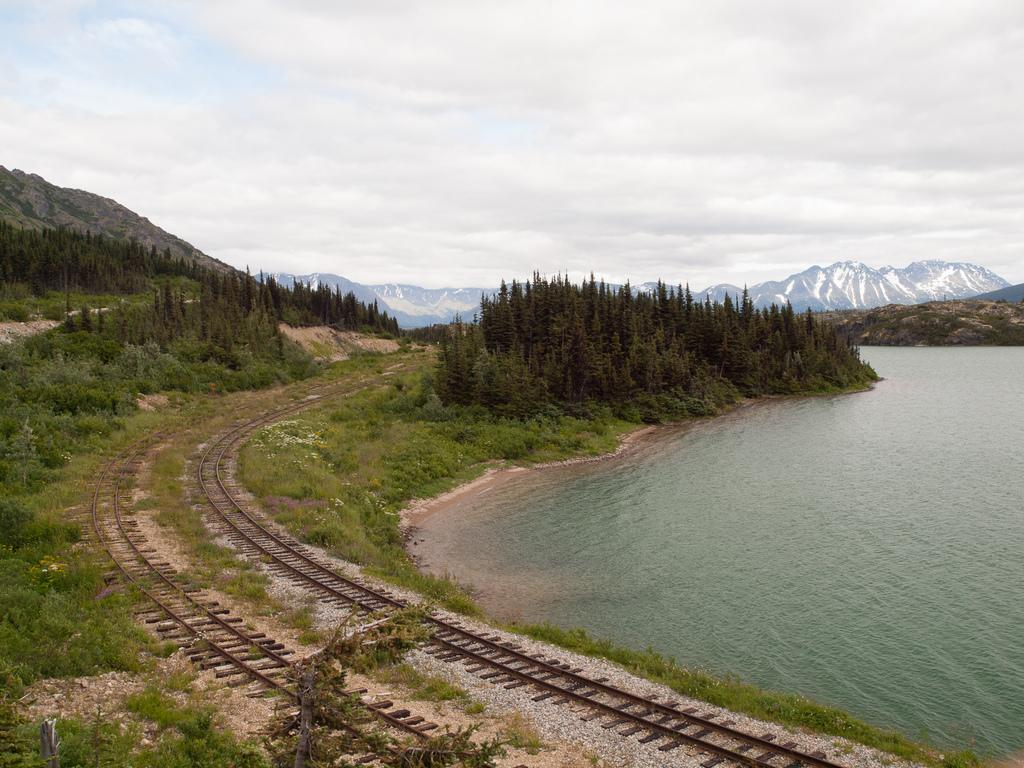What type of transportation infrastructure is present in the image? There is a railway track in the image. What type of vegetation can be seen in the image? There are plants and trees visible in the image. What geographical features are present in the image? There are mountains and water visible in the image. What is visible in the background of the image? The sky is visible in the background of the image, with clouds present. What type of yam is being used to write a verse in the image? There is no yam or verse present in the image. How does the image demonstrate respect for the environment? The image does not explicitly demonstrate respect for the environment, but it does showcase natural elements such as plants, trees, mountains, water, and sky. 